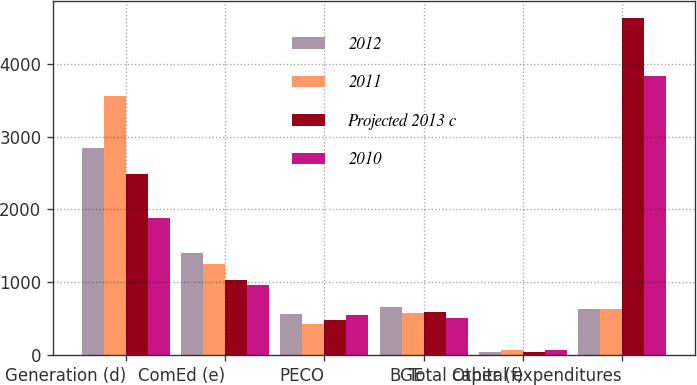Convert chart. <chart><loc_0><loc_0><loc_500><loc_500><stacked_bar_chart><ecel><fcel>Generation (d)<fcel>ComEd (e)<fcel>PECO<fcel>BGE<fcel>Other (f)<fcel>Total capital expenditures<nl><fcel>2012<fcel>2850<fcel>1400<fcel>569<fcel>663<fcel>43<fcel>627.5<nl><fcel>2011<fcel>3554<fcel>1246<fcel>422<fcel>582<fcel>67<fcel>627.5<nl><fcel>Projected 2013 c<fcel>2491<fcel>1028<fcel>481<fcel>592<fcel>42<fcel>4634<nl><fcel>2010<fcel>1883<fcel>962<fcel>545<fcel>508<fcel>64<fcel>3834<nl></chart> 